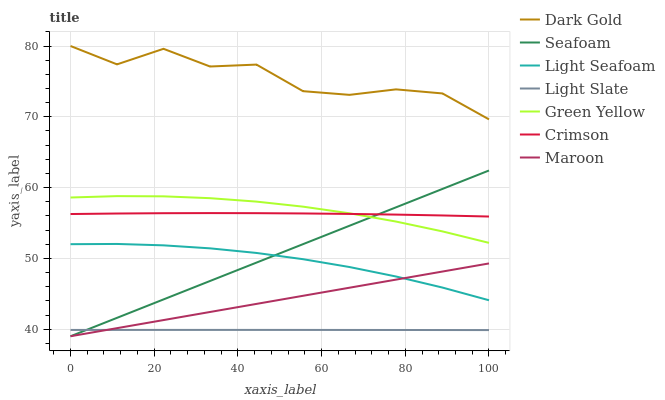Does Light Slate have the minimum area under the curve?
Answer yes or no. Yes. Does Dark Gold have the maximum area under the curve?
Answer yes or no. Yes. Does Dark Gold have the minimum area under the curve?
Answer yes or no. No. Does Light Slate have the maximum area under the curve?
Answer yes or no. No. Is Seafoam the smoothest?
Answer yes or no. Yes. Is Dark Gold the roughest?
Answer yes or no. Yes. Is Light Slate the smoothest?
Answer yes or no. No. Is Light Slate the roughest?
Answer yes or no. No. Does Light Slate have the lowest value?
Answer yes or no. No. Does Light Slate have the highest value?
Answer yes or no. No. Is Light Slate less than Crimson?
Answer yes or no. Yes. Is Dark Gold greater than Light Seafoam?
Answer yes or no. Yes. Does Light Slate intersect Crimson?
Answer yes or no. No. 